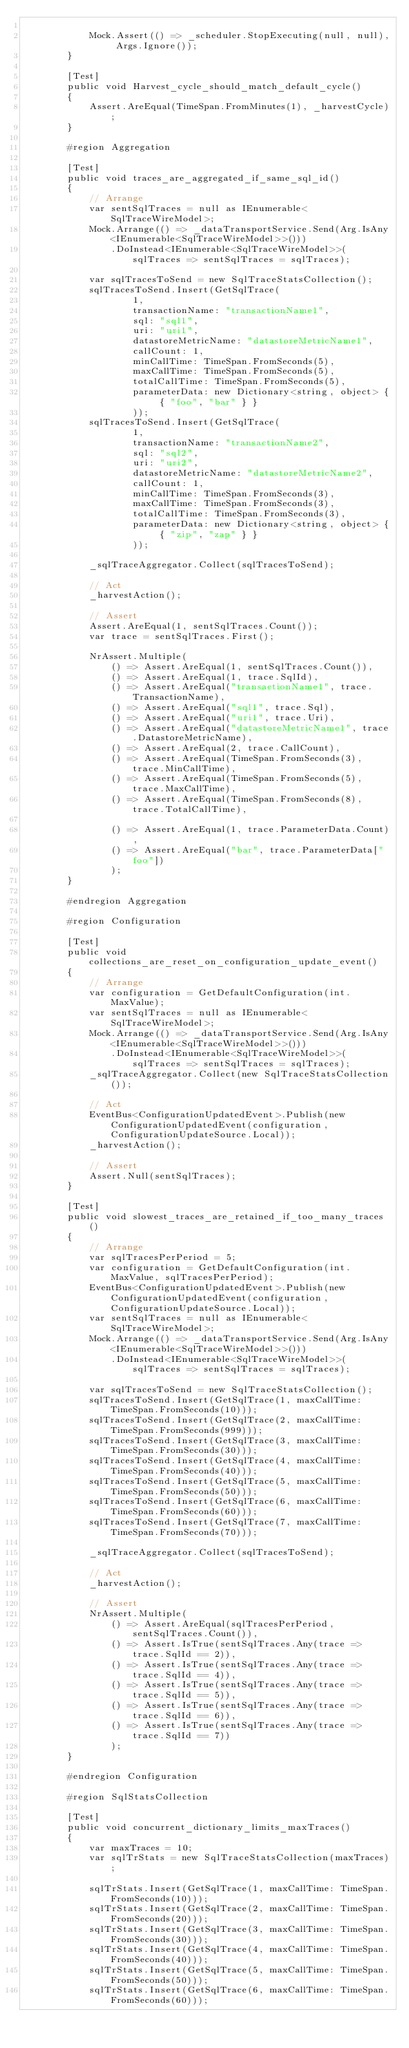<code> <loc_0><loc_0><loc_500><loc_500><_C#_>
            Mock.Assert(() => _scheduler.StopExecuting(null, null), Args.Ignore());
        }

        [Test]
        public void Harvest_cycle_should_match_default_cycle()
        {
            Assert.AreEqual(TimeSpan.FromMinutes(1), _harvestCycle);
        }

        #region Aggregation

        [Test]
        public void traces_are_aggregated_if_same_sql_id()
        {
            // Arrange
            var sentSqlTraces = null as IEnumerable<SqlTraceWireModel>;
            Mock.Arrange(() => _dataTransportService.Send(Arg.IsAny<IEnumerable<SqlTraceWireModel>>()))
                .DoInstead<IEnumerable<SqlTraceWireModel>>(sqlTraces => sentSqlTraces = sqlTraces);

            var sqlTracesToSend = new SqlTraceStatsCollection();
            sqlTracesToSend.Insert(GetSqlTrace(
                    1,
                    transactionName: "transactionName1",
                    sql: "sql1",
                    uri: "uri1",
                    datastoreMetricName: "datastoreMetricName1",
                    callCount: 1,
                    minCallTime: TimeSpan.FromSeconds(5),
                    maxCallTime: TimeSpan.FromSeconds(5),
                    totalCallTime: TimeSpan.FromSeconds(5),
                    parameterData: new Dictionary<string, object> { { "foo", "bar" } }
                    ));
            sqlTracesToSend.Insert(GetSqlTrace(
                    1,
                    transactionName: "transactionName2",
                    sql: "sql2",
                    uri: "uri2",
                    datastoreMetricName: "datastoreMetricName2",
                    callCount: 1,
                    minCallTime: TimeSpan.FromSeconds(3),
                    maxCallTime: TimeSpan.FromSeconds(3),
                    totalCallTime: TimeSpan.FromSeconds(3),
                    parameterData: new Dictionary<string, object> { { "zip", "zap" } }
                    ));

            _sqlTraceAggregator.Collect(sqlTracesToSend);

            // Act
            _harvestAction();

            // Assert
            Assert.AreEqual(1, sentSqlTraces.Count());
            var trace = sentSqlTraces.First();

            NrAssert.Multiple(
                () => Assert.AreEqual(1, sentSqlTraces.Count()),
                () => Assert.AreEqual(1, trace.SqlId),
                () => Assert.AreEqual("transactionName1", trace.TransactionName),
                () => Assert.AreEqual("sql1", trace.Sql),
                () => Assert.AreEqual("uri1", trace.Uri),
                () => Assert.AreEqual("datastoreMetricName1", trace.DatastoreMetricName),
                () => Assert.AreEqual(2, trace.CallCount),
                () => Assert.AreEqual(TimeSpan.FromSeconds(3), trace.MinCallTime),
                () => Assert.AreEqual(TimeSpan.FromSeconds(5), trace.MaxCallTime),
                () => Assert.AreEqual(TimeSpan.FromSeconds(8), trace.TotalCallTime),

                () => Assert.AreEqual(1, trace.ParameterData.Count),
                () => Assert.AreEqual("bar", trace.ParameterData["foo"])
                );
        }

        #endregion Aggregation

        #region Configuration

        [Test]
        public void collections_are_reset_on_configuration_update_event()
        {
            // Arrange
            var configuration = GetDefaultConfiguration(int.MaxValue);
            var sentSqlTraces = null as IEnumerable<SqlTraceWireModel>;
            Mock.Arrange(() => _dataTransportService.Send(Arg.IsAny<IEnumerable<SqlTraceWireModel>>()))
                .DoInstead<IEnumerable<SqlTraceWireModel>>(sqlTraces => sentSqlTraces = sqlTraces);
            _sqlTraceAggregator.Collect(new SqlTraceStatsCollection());

            // Act
            EventBus<ConfigurationUpdatedEvent>.Publish(new ConfigurationUpdatedEvent(configuration, ConfigurationUpdateSource.Local));
            _harvestAction();

            // Assert
            Assert.Null(sentSqlTraces);
        }

        [Test]
        public void slowest_traces_are_retained_if_too_many_traces()
        {
            // Arrange
            var sqlTracesPerPeriod = 5;
            var configuration = GetDefaultConfiguration(int.MaxValue, sqlTracesPerPeriod);
            EventBus<ConfigurationUpdatedEvent>.Publish(new ConfigurationUpdatedEvent(configuration, ConfigurationUpdateSource.Local));
            var sentSqlTraces = null as IEnumerable<SqlTraceWireModel>;
            Mock.Arrange(() => _dataTransportService.Send(Arg.IsAny<IEnumerable<SqlTraceWireModel>>()))
                .DoInstead<IEnumerable<SqlTraceWireModel>>(sqlTraces => sentSqlTraces = sqlTraces);

            var sqlTracesToSend = new SqlTraceStatsCollection();
            sqlTracesToSend.Insert(GetSqlTrace(1, maxCallTime: TimeSpan.FromSeconds(10)));
            sqlTracesToSend.Insert(GetSqlTrace(2, maxCallTime: TimeSpan.FromSeconds(999)));
            sqlTracesToSend.Insert(GetSqlTrace(3, maxCallTime: TimeSpan.FromSeconds(30)));
            sqlTracesToSend.Insert(GetSqlTrace(4, maxCallTime: TimeSpan.FromSeconds(40)));
            sqlTracesToSend.Insert(GetSqlTrace(5, maxCallTime: TimeSpan.FromSeconds(50)));
            sqlTracesToSend.Insert(GetSqlTrace(6, maxCallTime: TimeSpan.FromSeconds(60)));
            sqlTracesToSend.Insert(GetSqlTrace(7, maxCallTime: TimeSpan.FromSeconds(70)));

            _sqlTraceAggregator.Collect(sqlTracesToSend);

            // Act
            _harvestAction();

            // Assert
            NrAssert.Multiple(
                () => Assert.AreEqual(sqlTracesPerPeriod, sentSqlTraces.Count()),
                () => Assert.IsTrue(sentSqlTraces.Any(trace => trace.SqlId == 2)),
                () => Assert.IsTrue(sentSqlTraces.Any(trace => trace.SqlId == 4)),
                () => Assert.IsTrue(sentSqlTraces.Any(trace => trace.SqlId == 5)),
                () => Assert.IsTrue(sentSqlTraces.Any(trace => trace.SqlId == 6)),
                () => Assert.IsTrue(sentSqlTraces.Any(trace => trace.SqlId == 7))
                );
        }

        #endregion Configuration

        #region SqlStatsCollection

        [Test]
        public void concurrent_dictionary_limits_maxTraces()
        {
            var maxTraces = 10;
            var sqlTrStats = new SqlTraceStatsCollection(maxTraces);

            sqlTrStats.Insert(GetSqlTrace(1, maxCallTime: TimeSpan.FromSeconds(10)));
            sqlTrStats.Insert(GetSqlTrace(2, maxCallTime: TimeSpan.FromSeconds(20)));
            sqlTrStats.Insert(GetSqlTrace(3, maxCallTime: TimeSpan.FromSeconds(30)));
            sqlTrStats.Insert(GetSqlTrace(4, maxCallTime: TimeSpan.FromSeconds(40)));
            sqlTrStats.Insert(GetSqlTrace(5, maxCallTime: TimeSpan.FromSeconds(50)));
            sqlTrStats.Insert(GetSqlTrace(6, maxCallTime: TimeSpan.FromSeconds(60)));</code> 